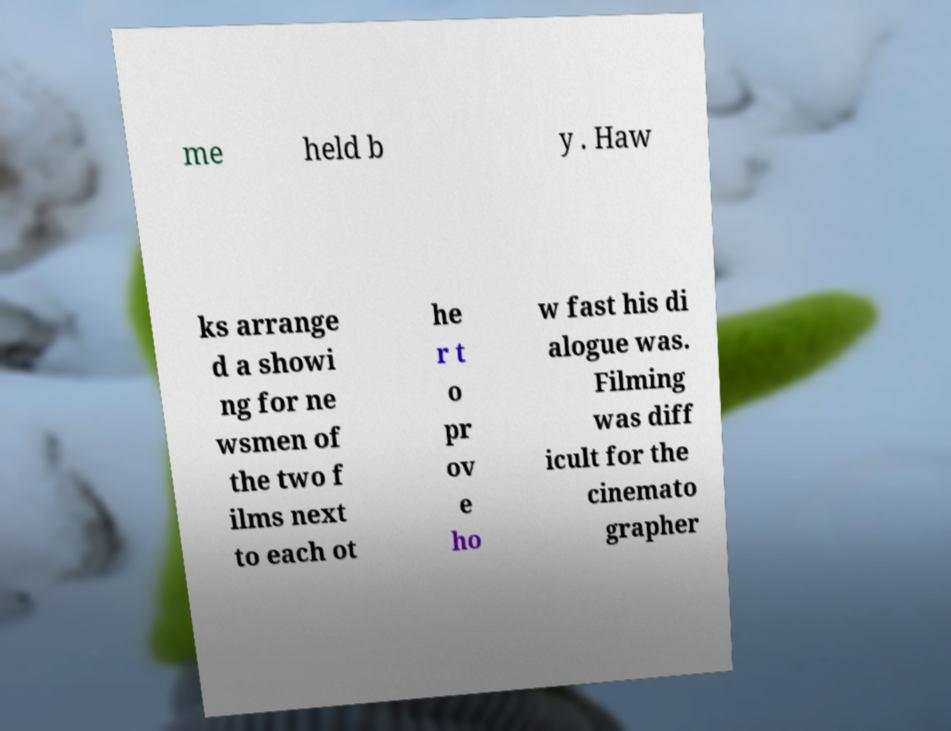Can you accurately transcribe the text from the provided image for me? me held b y . Haw ks arrange d a showi ng for ne wsmen of the two f ilms next to each ot he r t o pr ov e ho w fast his di alogue was. Filming was diff icult for the cinemato grapher 